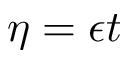<formula> <loc_0><loc_0><loc_500><loc_500>\eta = \epsilon t</formula> 